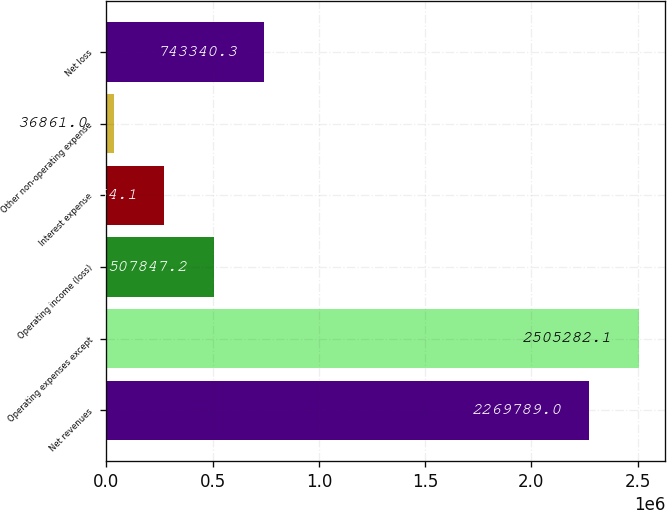Convert chart. <chart><loc_0><loc_0><loc_500><loc_500><bar_chart><fcel>Net revenues<fcel>Operating expenses except<fcel>Operating income (loss)<fcel>Interest expense<fcel>Other non-operating expense<fcel>Net loss<nl><fcel>2.26979e+06<fcel>2.50528e+06<fcel>507847<fcel>272354<fcel>36861<fcel>743340<nl></chart> 